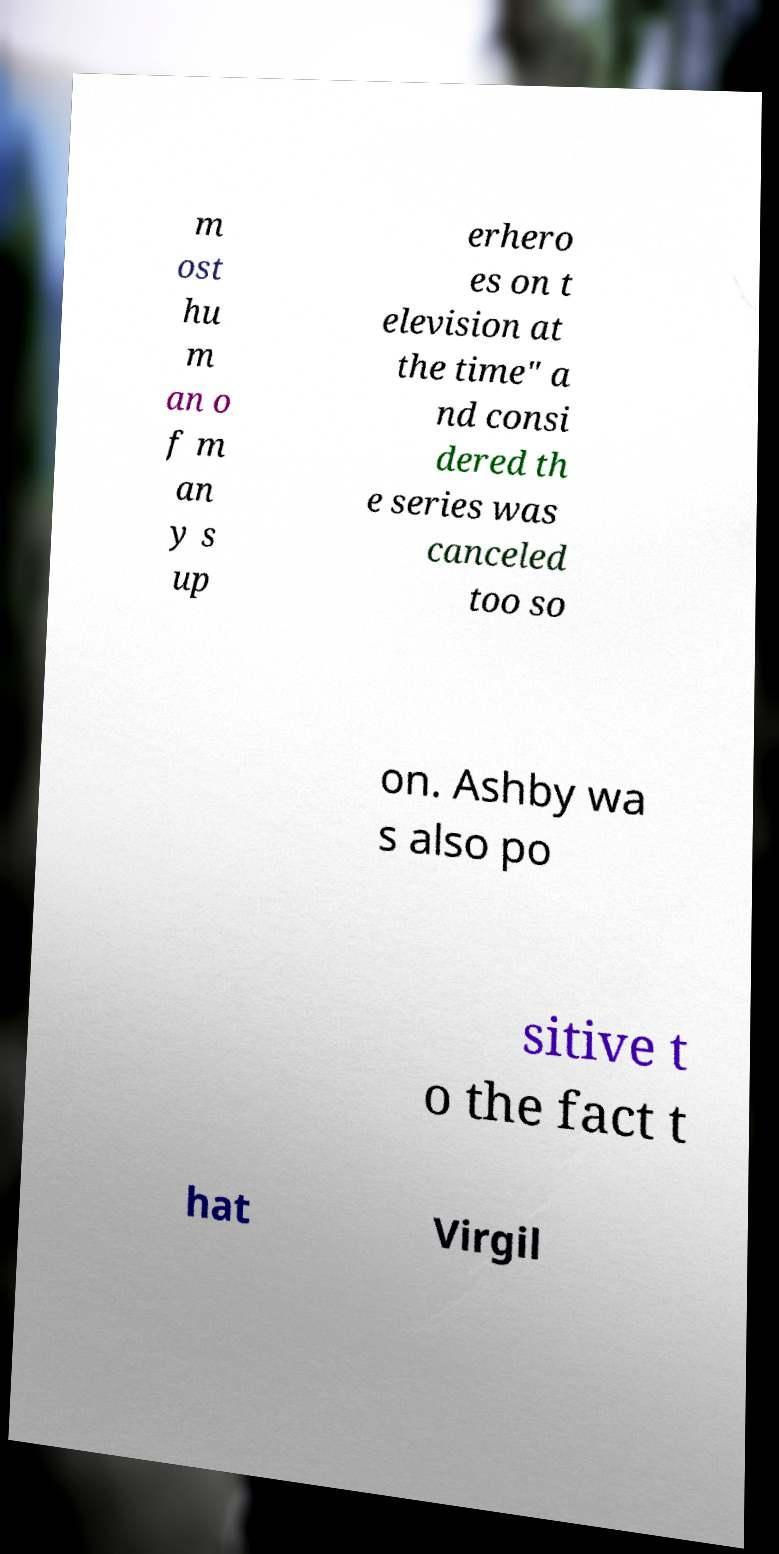Can you read and provide the text displayed in the image?This photo seems to have some interesting text. Can you extract and type it out for me? m ost hu m an o f m an y s up erhero es on t elevision at the time" a nd consi dered th e series was canceled too so on. Ashby wa s also po sitive t o the fact t hat Virgil 